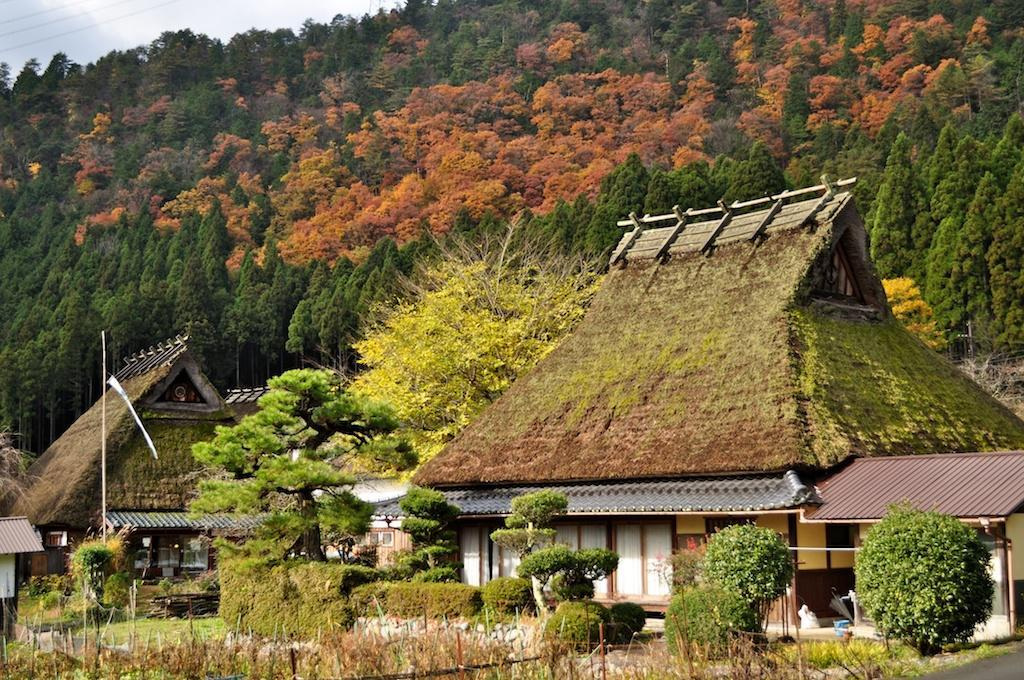What type of structures can be seen in the image? There are houses in the image. What other natural elements are present in the image? There are plants, trees, and stones visible in the image. Are there any man-made objects in the image besides the houses? Yes, there are poles in the image. What part of the natural environment is visible in the image? The sky is visible in the image. Can you see a nest in the image? No, there is no nest present in the image. 